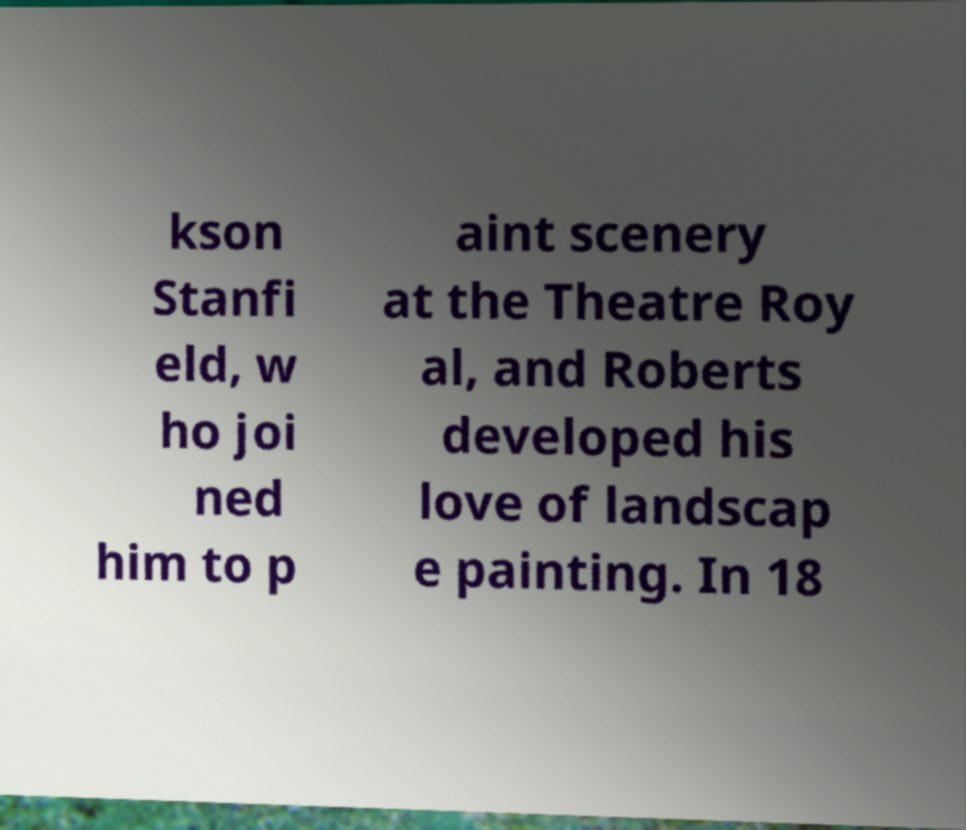There's text embedded in this image that I need extracted. Can you transcribe it verbatim? kson Stanfi eld, w ho joi ned him to p aint scenery at the Theatre Roy al, and Roberts developed his love of landscap e painting. In 18 